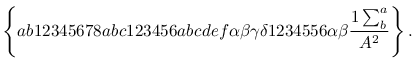Convert formula to latex. <formula><loc_0><loc_0><loc_500><loc_500>\left \{ a b 1 2 3 4 5 6 7 8 a b c 1 2 3 4 5 6 a b c d e f \alpha \beta \gamma \delta 1 2 3 4 5 5 6 \alpha \beta \frac { 1 \sum _ { b } ^ { a } } { A ^ { 2 } } \right \} .</formula> 